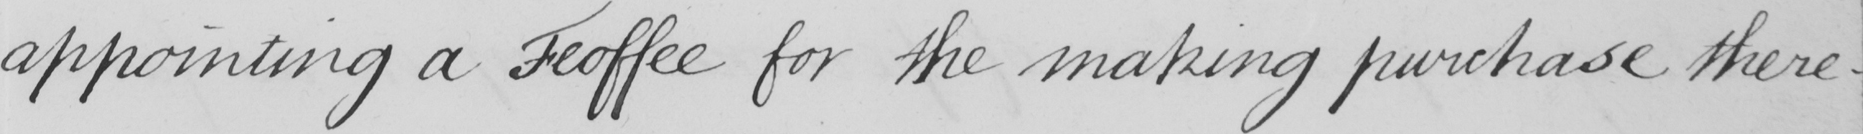Can you tell me what this handwritten text says? appointing a Feoffee for the making purchase there- 